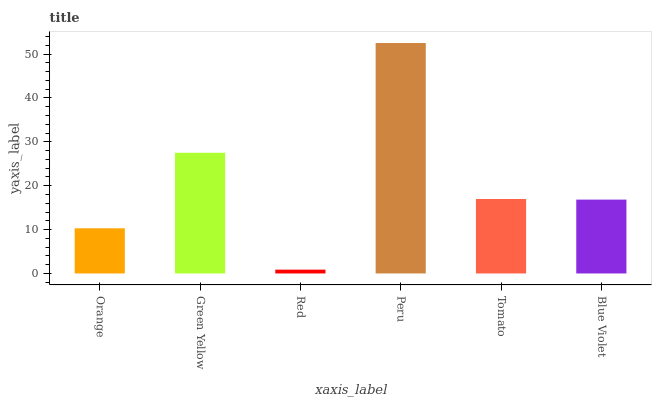Is Red the minimum?
Answer yes or no. Yes. Is Peru the maximum?
Answer yes or no. Yes. Is Green Yellow the minimum?
Answer yes or no. No. Is Green Yellow the maximum?
Answer yes or no. No. Is Green Yellow greater than Orange?
Answer yes or no. Yes. Is Orange less than Green Yellow?
Answer yes or no. Yes. Is Orange greater than Green Yellow?
Answer yes or no. No. Is Green Yellow less than Orange?
Answer yes or no. No. Is Tomato the high median?
Answer yes or no. Yes. Is Blue Violet the low median?
Answer yes or no. Yes. Is Red the high median?
Answer yes or no. No. Is Red the low median?
Answer yes or no. No. 